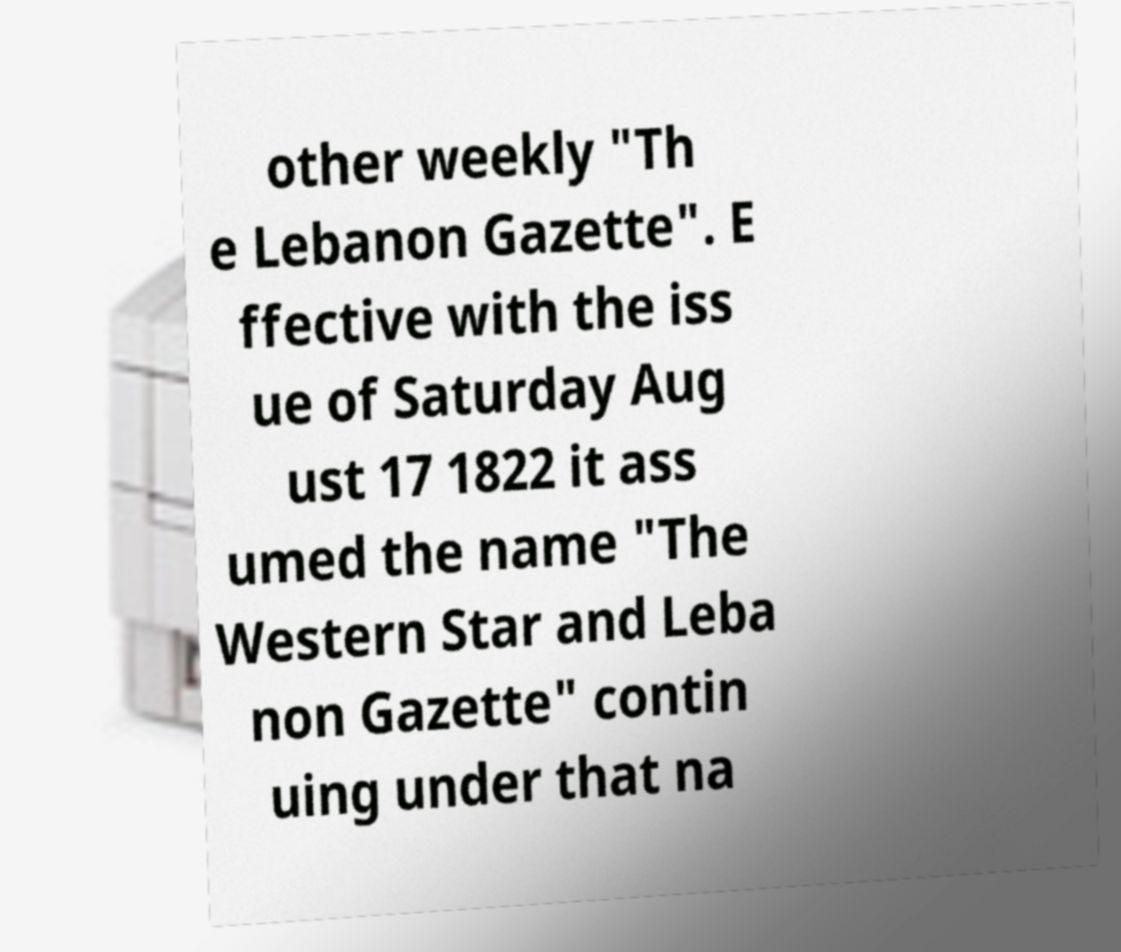Could you extract and type out the text from this image? other weekly "Th e Lebanon Gazette". E ffective with the iss ue of Saturday Aug ust 17 1822 it ass umed the name "The Western Star and Leba non Gazette" contin uing under that na 